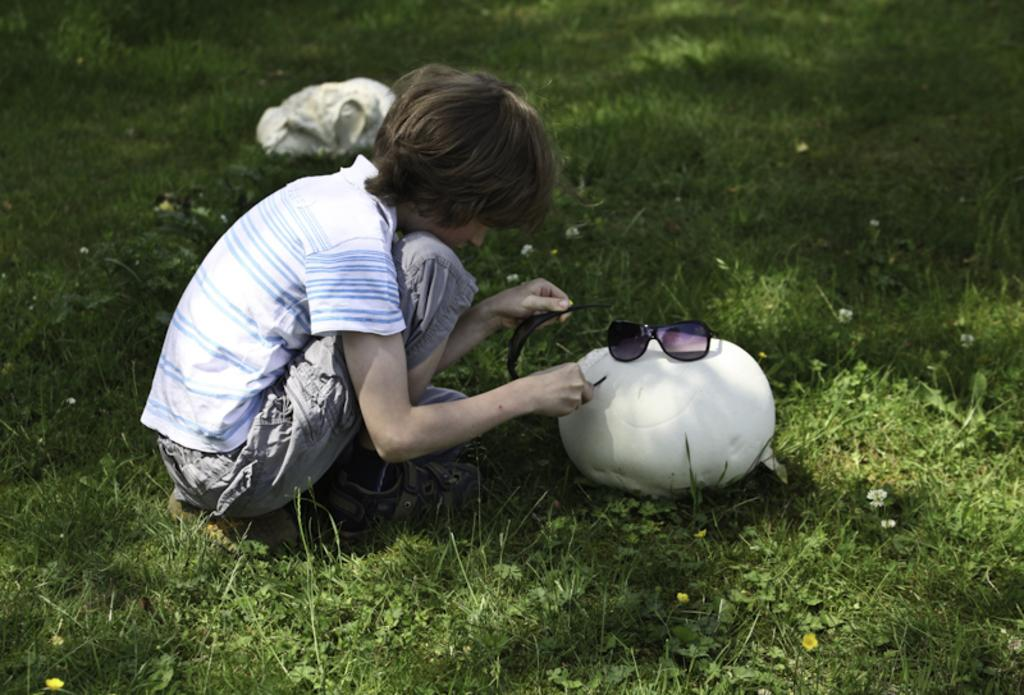What is the main subject of the image? There is a child in the image. What is the child holding in the image? The child is holding goggles. What can be seen on the grass in the image? There are objects on the grass. Are there any goggles visible on an object in the image? Yes, there are goggles on an object in the image. What type of news is the child reading from the goggles in the image? The image does not show the child reading any news from the goggles, as goggles are typically used for eye protection and not for reading. 